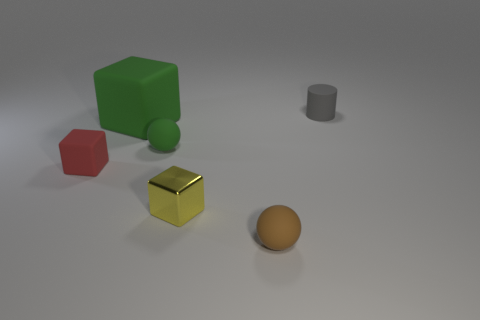Subtract all yellow metal blocks. How many blocks are left? 2 Subtract all cylinders. How many objects are left? 5 Add 5 tiny rubber blocks. How many tiny rubber blocks are left? 6 Add 3 brown things. How many brown things exist? 4 Add 4 big blue cylinders. How many objects exist? 10 Subtract all green blocks. How many blocks are left? 2 Subtract 0 yellow balls. How many objects are left? 6 Subtract 2 balls. How many balls are left? 0 Subtract all gray spheres. Subtract all yellow cubes. How many spheres are left? 2 Subtract all green spheres. How many red cubes are left? 1 